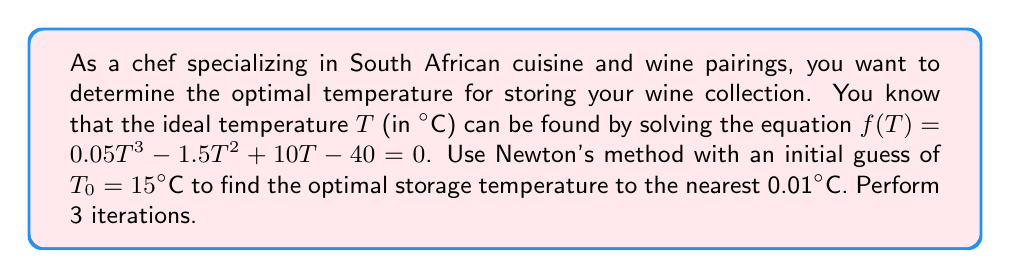Can you answer this question? Newton's method is given by the formula:

$$T_{n+1} = T_n - \frac{f(T_n)}{f'(T_n)}$$

where $f'(T)$ is the derivative of $f(T)$.

Step 1: Calculate $f'(T)$
$$f'(T) = 0.15T^2 - 3T + 10$$

Step 2: Implement Newton's method
Iteration 1:
$$f(15) = 0.05(15)^3 - 1.5(15)^2 + 10(15) - 40 = -11.25$$
$$f'(15) = 0.15(15)^2 - 3(15) + 10 = 13.75$$
$$T_1 = 15 - \frac{-11.25}{13.75} = 15.82°C$$

Iteration 2:
$$f(15.82) = 0.05(15.82)^3 - 1.5(15.82)^2 + 10(15.82) - 40 = -0.45$$
$$f'(15.82) = 0.15(15.82)^2 - 3(15.82) + 10 = 11.95$$
$$T_2 = 15.82 - \frac{-0.45}{11.95} = 15.86°C$$

Iteration 3:
$$f(15.86) = 0.05(15.86)^3 - 1.5(15.86)^2 + 10(15.86) - 40 = -0.0015$$
$$f'(15.86) = 0.15(15.86)^2 - 3(15.86) + 10 = 11.88$$
$$T_3 = 15.86 - \frac{-0.0015}{11.88} = 15.86°C$$

The optimal temperature after 3 iterations, rounded to the nearest 0.01°C, is 15.86°C.
Answer: 15.86°C 